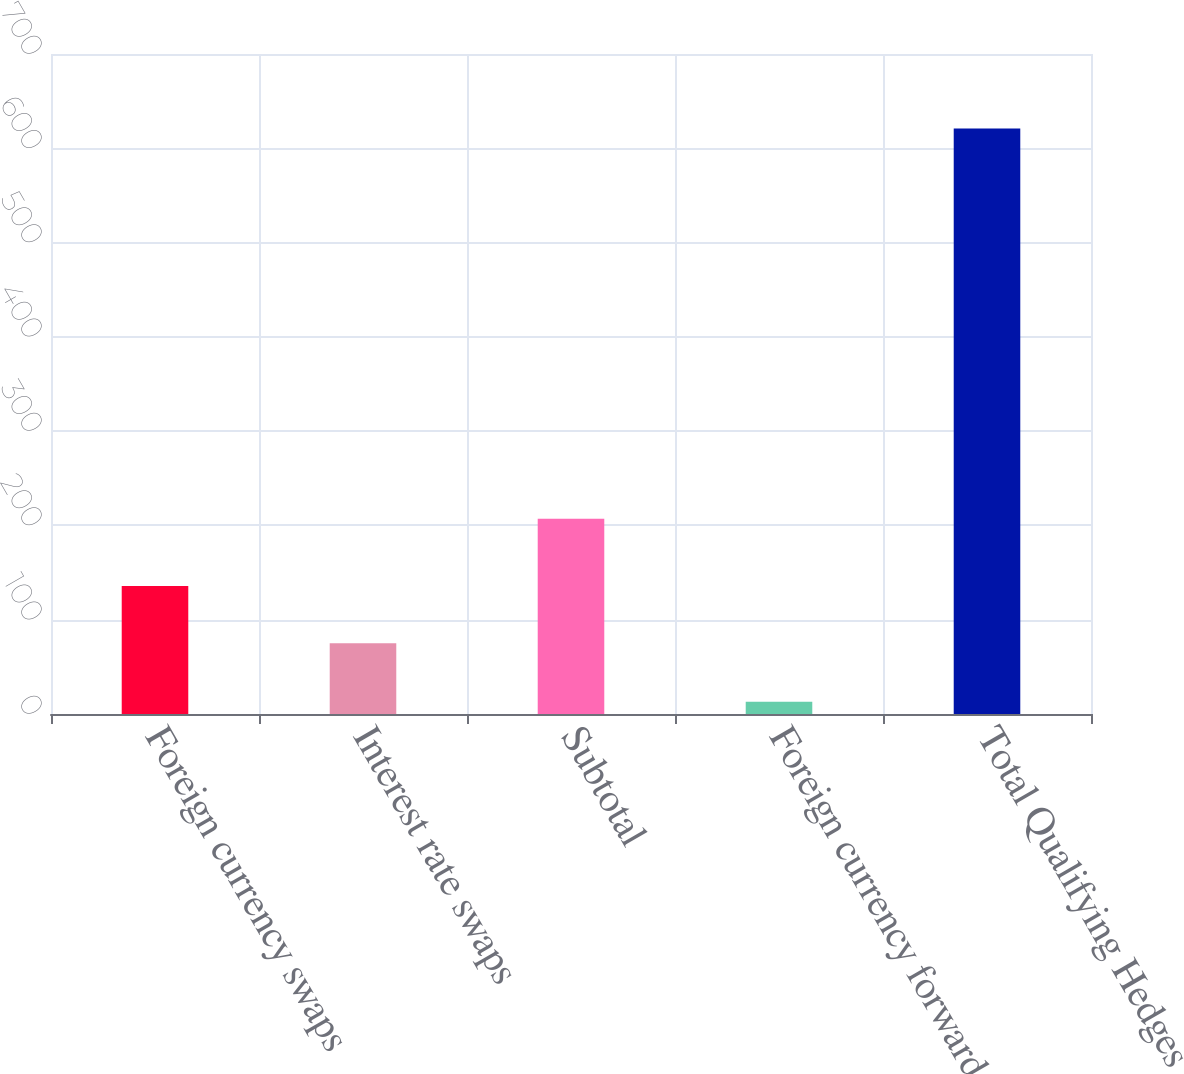<chart> <loc_0><loc_0><loc_500><loc_500><bar_chart><fcel>Foreign currency swaps<fcel>Interest rate swaps<fcel>Subtotal<fcel>Foreign currency forwards<fcel>Total Qualifying Hedges<nl><fcel>135.8<fcel>75<fcel>207<fcel>13<fcel>621<nl></chart> 